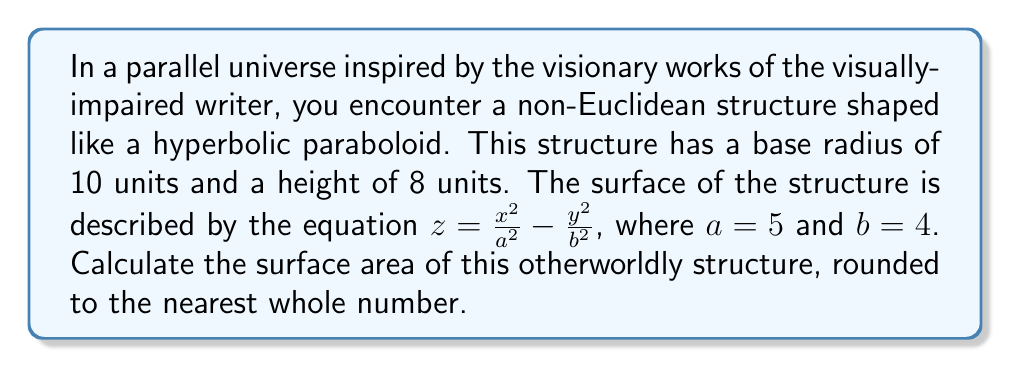Teach me how to tackle this problem. To find the surface area of the hyperbolic paraboloid, we need to use the surface area formula for a parametric surface:

$$SA = \int\int_R \sqrt{1 + \left(\frac{\partial z}{\partial x}\right)^2 + \left(\frac{\partial z}{\partial y}\right)^2} \, dA$$

Where $R$ is the region of integration, and $\frac{\partial z}{\partial x}$ and $\frac{\partial z}{\partial y}$ are partial derivatives.

Step 1: Calculate the partial derivatives
$$\frac{\partial z}{\partial x} = \frac{2x}{a^2} = \frac{2x}{25}$$
$$\frac{\partial z}{\partial y} = -\frac{2y}{b^2} = -\frac{2y}{16}$$

Step 2: Substitute into the surface area formula
$$SA = \int\int_R \sqrt{1 + \left(\frac{2x}{25}\right)^2 + \left(-\frac{2y}{16}\right)^2} \, dA$$

Step 3: Convert to polar coordinates
Let $x = r\cos\theta$ and $y = r\sin\theta$. The region $R$ is a circle with radius 10.

$$SA = \int_0^{2\pi} \int_0^{10} \sqrt{1 + \left(\frac{2r\cos\theta}{25}\right)^2 + \left(-\frac{2r\sin\theta}{16}\right)^2} \, r \, dr \, d\theta$$

Step 4: Simplify the integrand
$$SA = \int_0^{2\pi} \int_0^{10} \sqrt{1 + \frac{4r^2\cos^2\theta}{625} + \frac{4r^2\sin^2\theta}{256}} \, r \, dr \, d\theta$$

$$SA = \int_0^{2\pi} \int_0^{10} \sqrt{1 + \frac{4r^2}{625}(\cos^2\theta + \frac{625}{256}\sin^2\theta)} \, r \, dr \, d\theta$$

Step 5: This integral cannot be solved analytically, so we need to use numerical integration techniques. Using a computer algebra system or numerical integration software, we can approximate the result.
Answer: The surface area of the hyperbolic paraboloid structure is approximately 366 square units (rounded to the nearest whole number). 